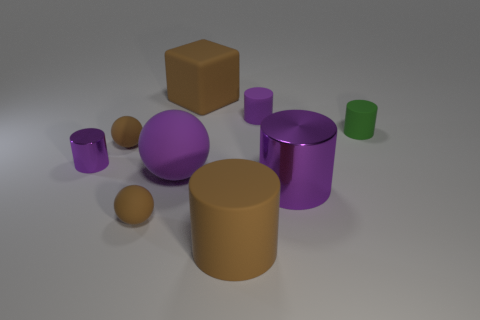Is the number of brown balls greater than the number of tiny blue shiny objects?
Your response must be concise. Yes. There is a rubber sphere that is behind the purple sphere to the left of the tiny green matte thing; are there any brown rubber spheres that are in front of it?
Provide a succinct answer. Yes. What number of other things are there of the same size as the brown matte cylinder?
Give a very brief answer. 3. There is a small green rubber cylinder; are there any brown matte spheres in front of it?
Provide a short and direct response. Yes. There is a small metal thing; is its color the same as the small ball in front of the big shiny object?
Provide a short and direct response. No. The shiny cylinder that is left of the large brown thing behind the large brown rubber thing that is right of the big brown rubber cube is what color?
Provide a succinct answer. Purple. Is there a small metallic thing that has the same shape as the big purple metal thing?
Offer a very short reply. Yes. There is a rubber cube that is the same size as the brown cylinder; what is its color?
Provide a succinct answer. Brown. There is a small cylinder behind the green object; what material is it?
Provide a short and direct response. Rubber. Does the shiny thing behind the big purple rubber sphere have the same shape as the big matte object that is behind the big rubber ball?
Your response must be concise. No. 